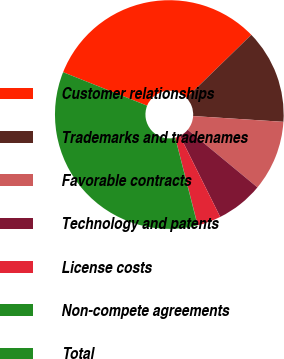<chart> <loc_0><loc_0><loc_500><loc_500><pie_chart><fcel>Customer relationships<fcel>Trademarks and tradenames<fcel>Favorable contracts<fcel>Technology and patents<fcel>License costs<fcel>Non-compete agreements<fcel>Total<nl><fcel>31.69%<fcel>13.29%<fcel>9.98%<fcel>6.66%<fcel>3.34%<fcel>0.03%<fcel>35.01%<nl></chart> 